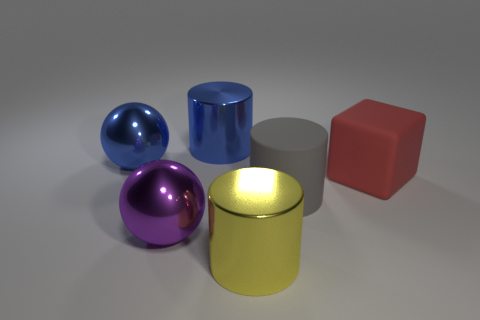Add 2 cylinders. How many objects exist? 8 Subtract all large shiny cylinders. How many cylinders are left? 1 Subtract all spheres. How many objects are left? 4 Subtract all brown cylinders. Subtract all green spheres. How many cylinders are left? 3 Subtract all yellow metallic spheres. Subtract all big matte things. How many objects are left? 4 Add 6 large red cubes. How many large red cubes are left? 7 Add 3 big metal balls. How many big metal balls exist? 5 Subtract 0 yellow spheres. How many objects are left? 6 